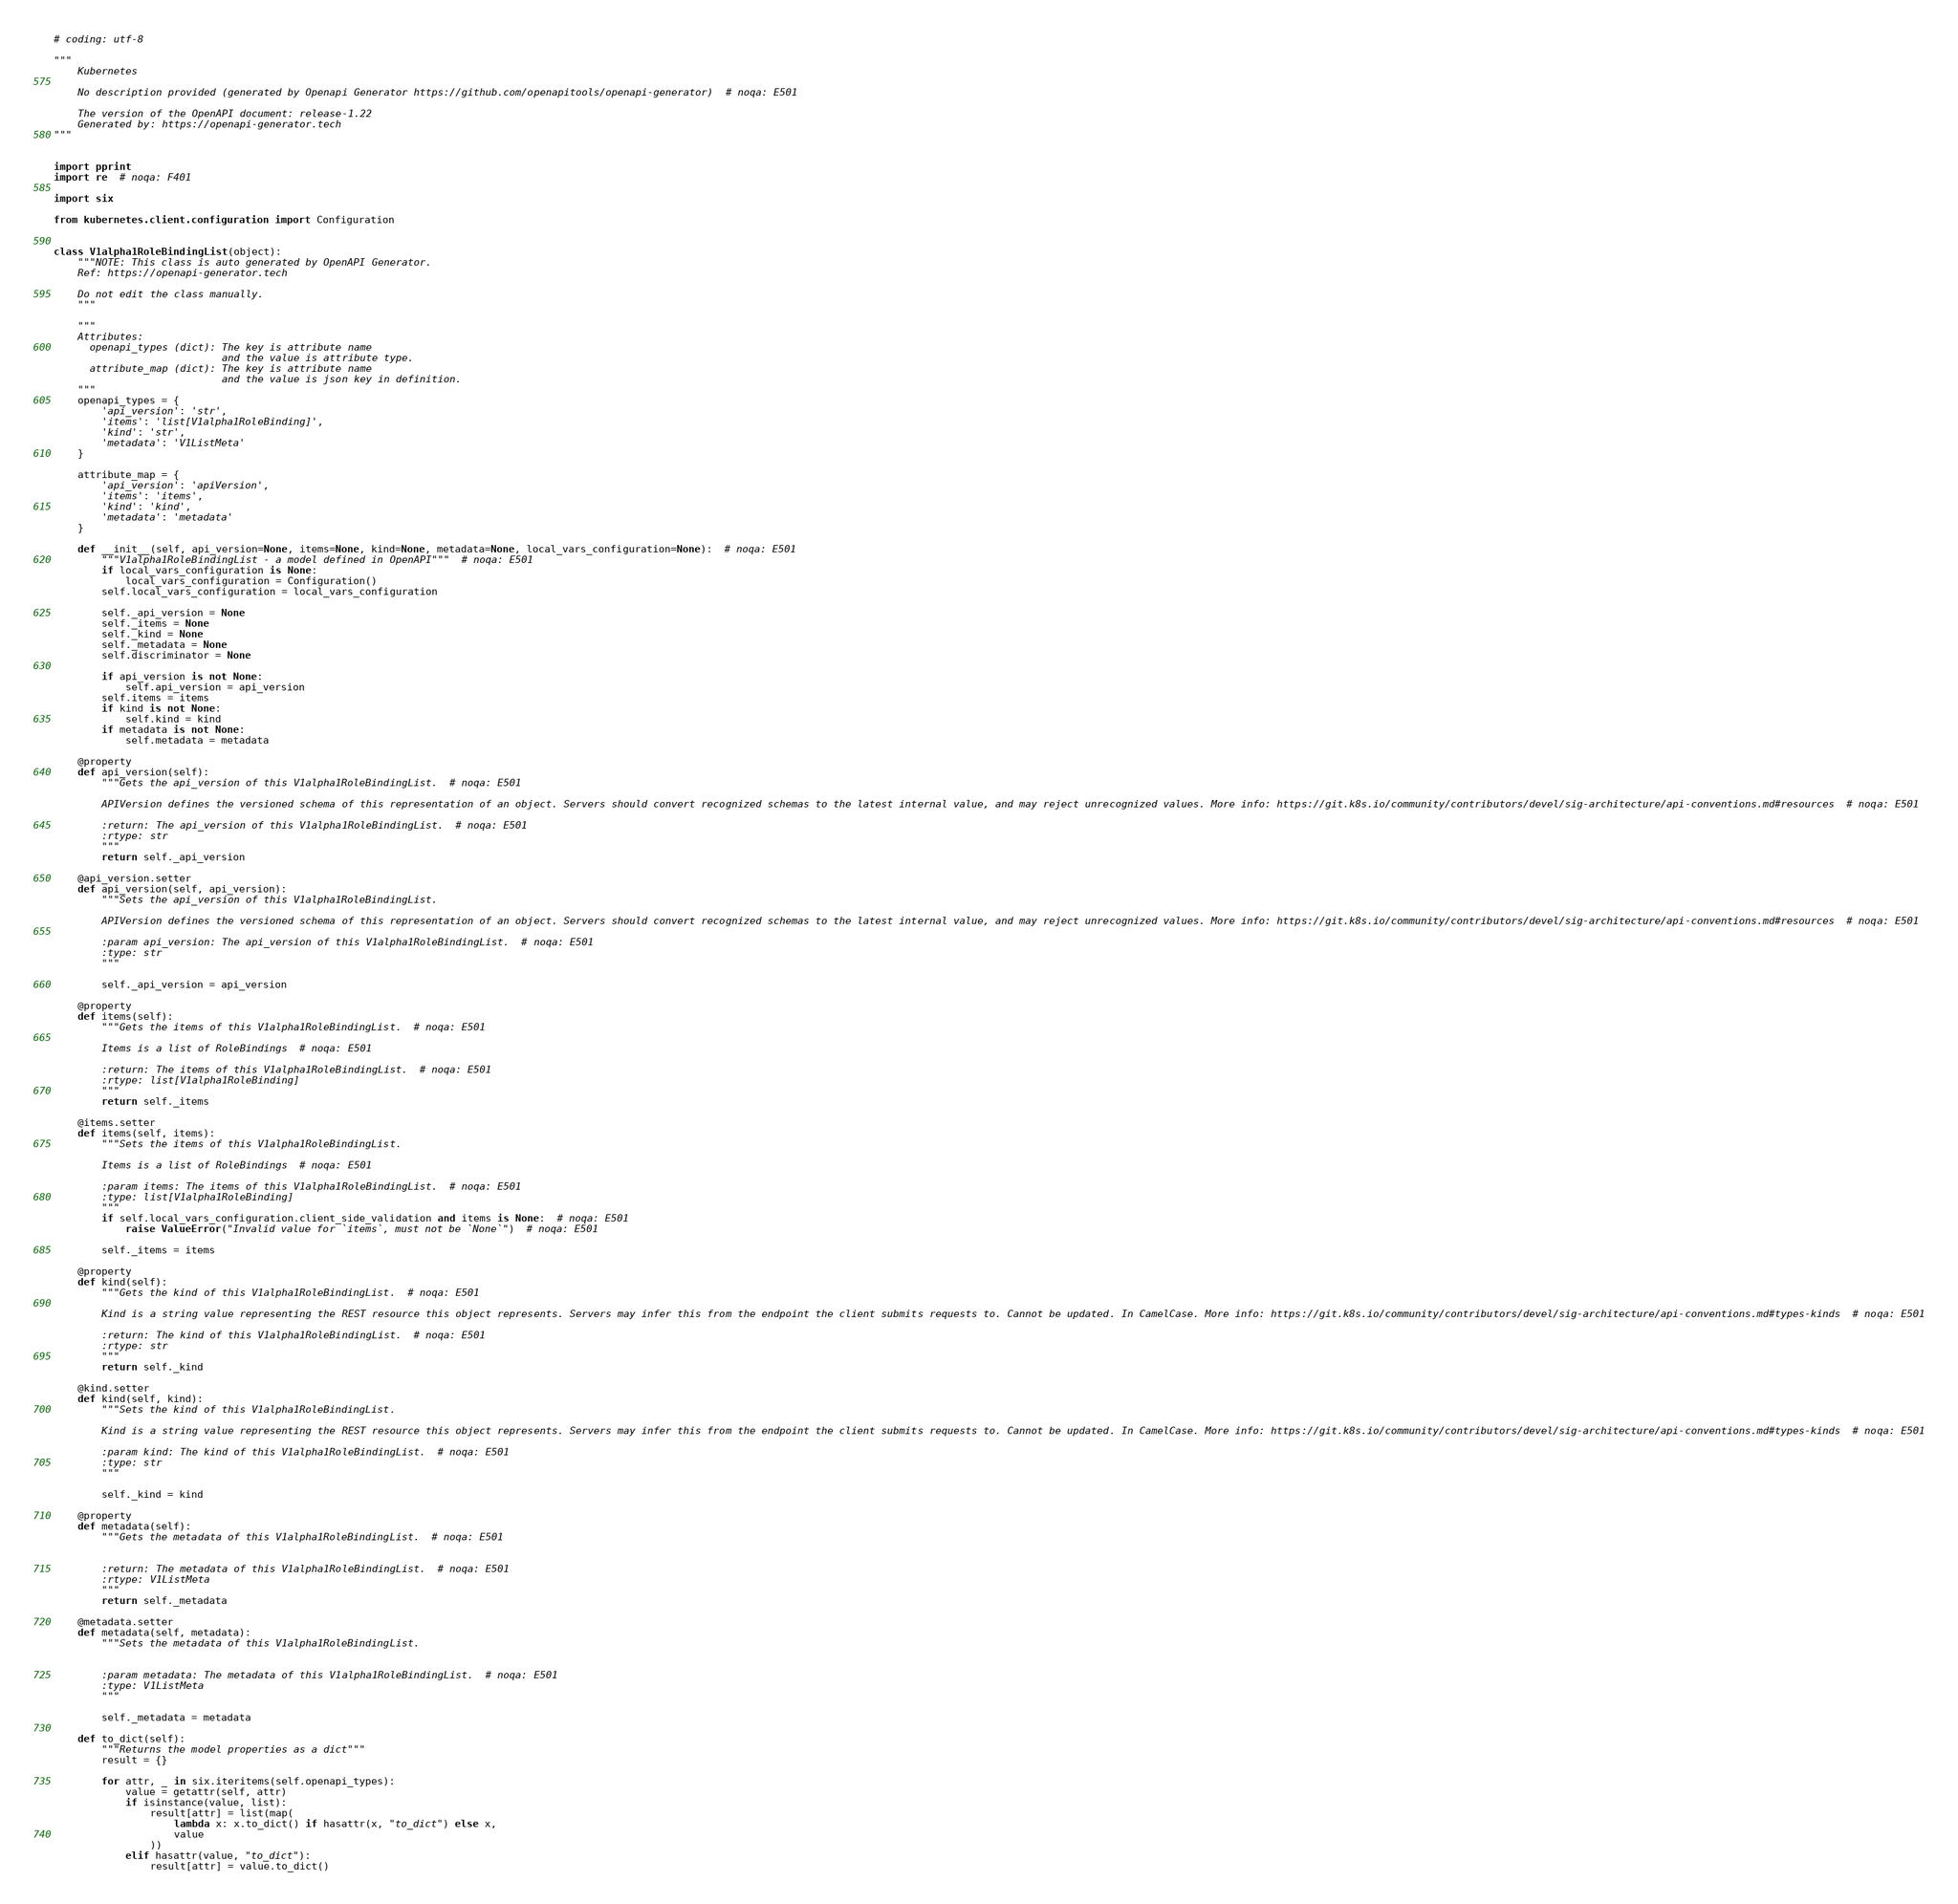Convert code to text. <code><loc_0><loc_0><loc_500><loc_500><_Python_># coding: utf-8

"""
    Kubernetes

    No description provided (generated by Openapi Generator https://github.com/openapitools/openapi-generator)  # noqa: E501

    The version of the OpenAPI document: release-1.22
    Generated by: https://openapi-generator.tech
"""


import pprint
import re  # noqa: F401

import six

from kubernetes.client.configuration import Configuration


class V1alpha1RoleBindingList(object):
    """NOTE: This class is auto generated by OpenAPI Generator.
    Ref: https://openapi-generator.tech

    Do not edit the class manually.
    """

    """
    Attributes:
      openapi_types (dict): The key is attribute name
                            and the value is attribute type.
      attribute_map (dict): The key is attribute name
                            and the value is json key in definition.
    """
    openapi_types = {
        'api_version': 'str',
        'items': 'list[V1alpha1RoleBinding]',
        'kind': 'str',
        'metadata': 'V1ListMeta'
    }

    attribute_map = {
        'api_version': 'apiVersion',
        'items': 'items',
        'kind': 'kind',
        'metadata': 'metadata'
    }

    def __init__(self, api_version=None, items=None, kind=None, metadata=None, local_vars_configuration=None):  # noqa: E501
        """V1alpha1RoleBindingList - a model defined in OpenAPI"""  # noqa: E501
        if local_vars_configuration is None:
            local_vars_configuration = Configuration()
        self.local_vars_configuration = local_vars_configuration

        self._api_version = None
        self._items = None
        self._kind = None
        self._metadata = None
        self.discriminator = None

        if api_version is not None:
            self.api_version = api_version
        self.items = items
        if kind is not None:
            self.kind = kind
        if metadata is not None:
            self.metadata = metadata

    @property
    def api_version(self):
        """Gets the api_version of this V1alpha1RoleBindingList.  # noqa: E501

        APIVersion defines the versioned schema of this representation of an object. Servers should convert recognized schemas to the latest internal value, and may reject unrecognized values. More info: https://git.k8s.io/community/contributors/devel/sig-architecture/api-conventions.md#resources  # noqa: E501

        :return: The api_version of this V1alpha1RoleBindingList.  # noqa: E501
        :rtype: str
        """
        return self._api_version

    @api_version.setter
    def api_version(self, api_version):
        """Sets the api_version of this V1alpha1RoleBindingList.

        APIVersion defines the versioned schema of this representation of an object. Servers should convert recognized schemas to the latest internal value, and may reject unrecognized values. More info: https://git.k8s.io/community/contributors/devel/sig-architecture/api-conventions.md#resources  # noqa: E501

        :param api_version: The api_version of this V1alpha1RoleBindingList.  # noqa: E501
        :type: str
        """

        self._api_version = api_version

    @property
    def items(self):
        """Gets the items of this V1alpha1RoleBindingList.  # noqa: E501

        Items is a list of RoleBindings  # noqa: E501

        :return: The items of this V1alpha1RoleBindingList.  # noqa: E501
        :rtype: list[V1alpha1RoleBinding]
        """
        return self._items

    @items.setter
    def items(self, items):
        """Sets the items of this V1alpha1RoleBindingList.

        Items is a list of RoleBindings  # noqa: E501

        :param items: The items of this V1alpha1RoleBindingList.  # noqa: E501
        :type: list[V1alpha1RoleBinding]
        """
        if self.local_vars_configuration.client_side_validation and items is None:  # noqa: E501
            raise ValueError("Invalid value for `items`, must not be `None`")  # noqa: E501

        self._items = items

    @property
    def kind(self):
        """Gets the kind of this V1alpha1RoleBindingList.  # noqa: E501

        Kind is a string value representing the REST resource this object represents. Servers may infer this from the endpoint the client submits requests to. Cannot be updated. In CamelCase. More info: https://git.k8s.io/community/contributors/devel/sig-architecture/api-conventions.md#types-kinds  # noqa: E501

        :return: The kind of this V1alpha1RoleBindingList.  # noqa: E501
        :rtype: str
        """
        return self._kind

    @kind.setter
    def kind(self, kind):
        """Sets the kind of this V1alpha1RoleBindingList.

        Kind is a string value representing the REST resource this object represents. Servers may infer this from the endpoint the client submits requests to. Cannot be updated. In CamelCase. More info: https://git.k8s.io/community/contributors/devel/sig-architecture/api-conventions.md#types-kinds  # noqa: E501

        :param kind: The kind of this V1alpha1RoleBindingList.  # noqa: E501
        :type: str
        """

        self._kind = kind

    @property
    def metadata(self):
        """Gets the metadata of this V1alpha1RoleBindingList.  # noqa: E501


        :return: The metadata of this V1alpha1RoleBindingList.  # noqa: E501
        :rtype: V1ListMeta
        """
        return self._metadata

    @metadata.setter
    def metadata(self, metadata):
        """Sets the metadata of this V1alpha1RoleBindingList.


        :param metadata: The metadata of this V1alpha1RoleBindingList.  # noqa: E501
        :type: V1ListMeta
        """

        self._metadata = metadata

    def to_dict(self):
        """Returns the model properties as a dict"""
        result = {}

        for attr, _ in six.iteritems(self.openapi_types):
            value = getattr(self, attr)
            if isinstance(value, list):
                result[attr] = list(map(
                    lambda x: x.to_dict() if hasattr(x, "to_dict") else x,
                    value
                ))
            elif hasattr(value, "to_dict"):
                result[attr] = value.to_dict()</code> 